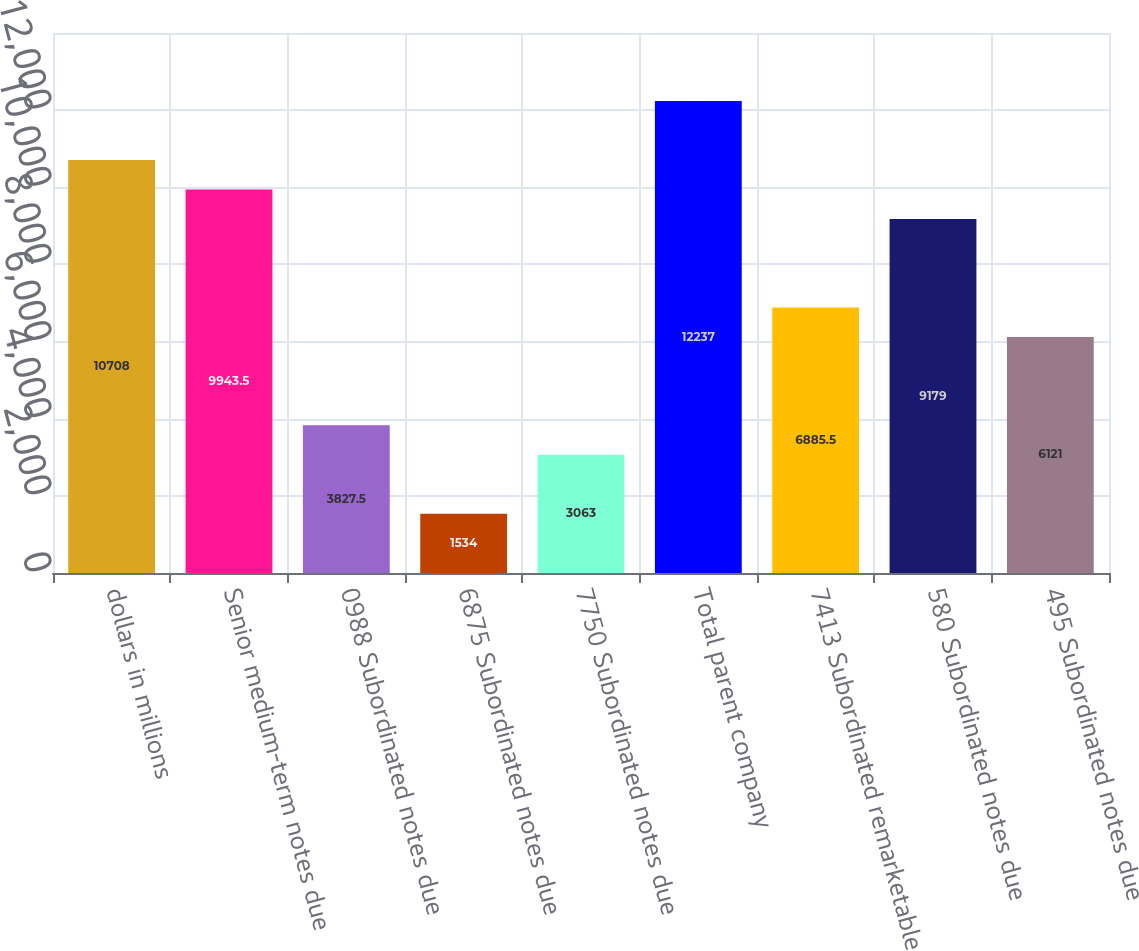Convert chart to OTSL. <chart><loc_0><loc_0><loc_500><loc_500><bar_chart><fcel>dollars in millions<fcel>Senior medium-term notes due<fcel>0988 Subordinated notes due<fcel>6875 Subordinated notes due<fcel>7750 Subordinated notes due<fcel>Total parent company<fcel>7413 Subordinated remarketable<fcel>580 Subordinated notes due<fcel>495 Subordinated notes due<nl><fcel>10708<fcel>9943.5<fcel>3827.5<fcel>1534<fcel>3063<fcel>12237<fcel>6885.5<fcel>9179<fcel>6121<nl></chart> 